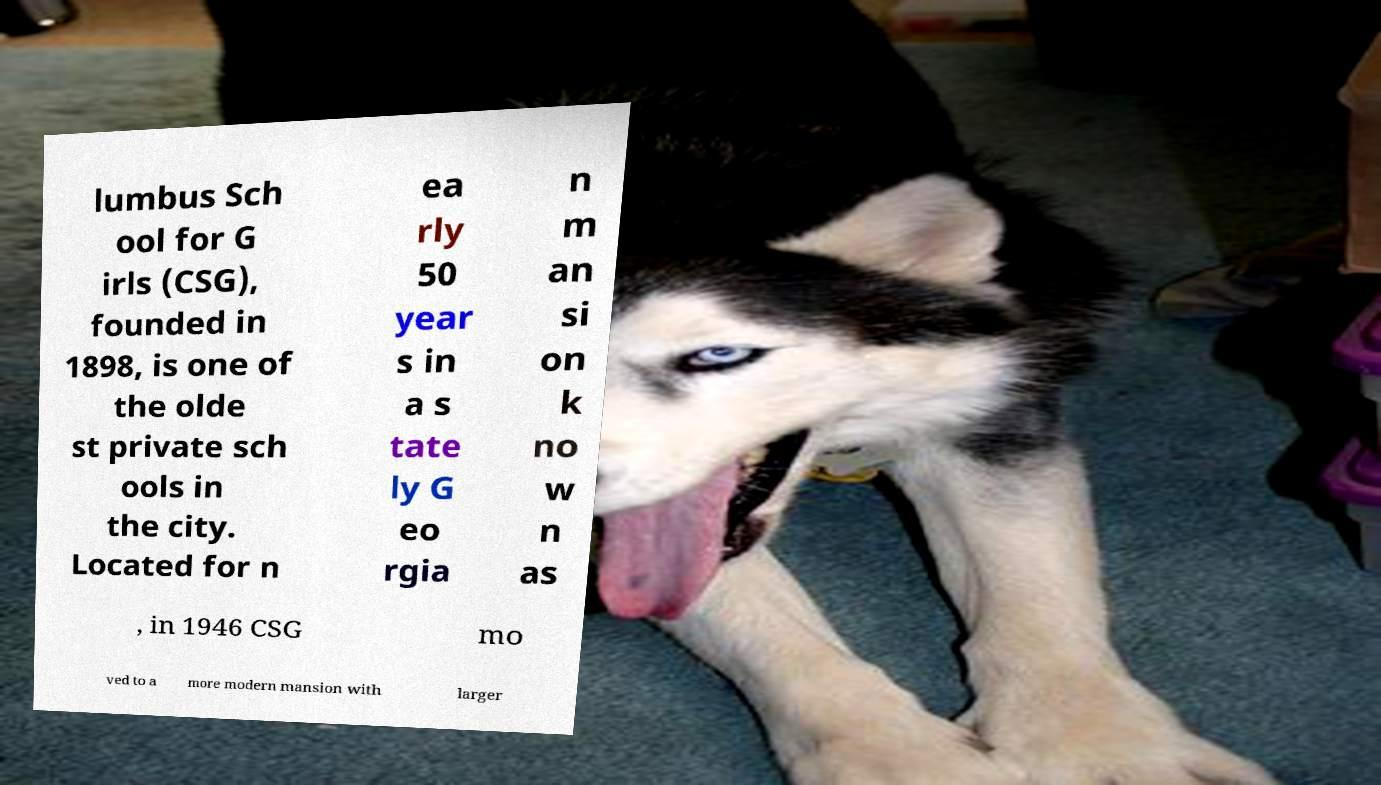I need the written content from this picture converted into text. Can you do that? lumbus Sch ool for G irls (CSG), founded in 1898, is one of the olde st private sch ools in the city. Located for n ea rly 50 year s in a s tate ly G eo rgia n m an si on k no w n as , in 1946 CSG mo ved to a more modern mansion with larger 